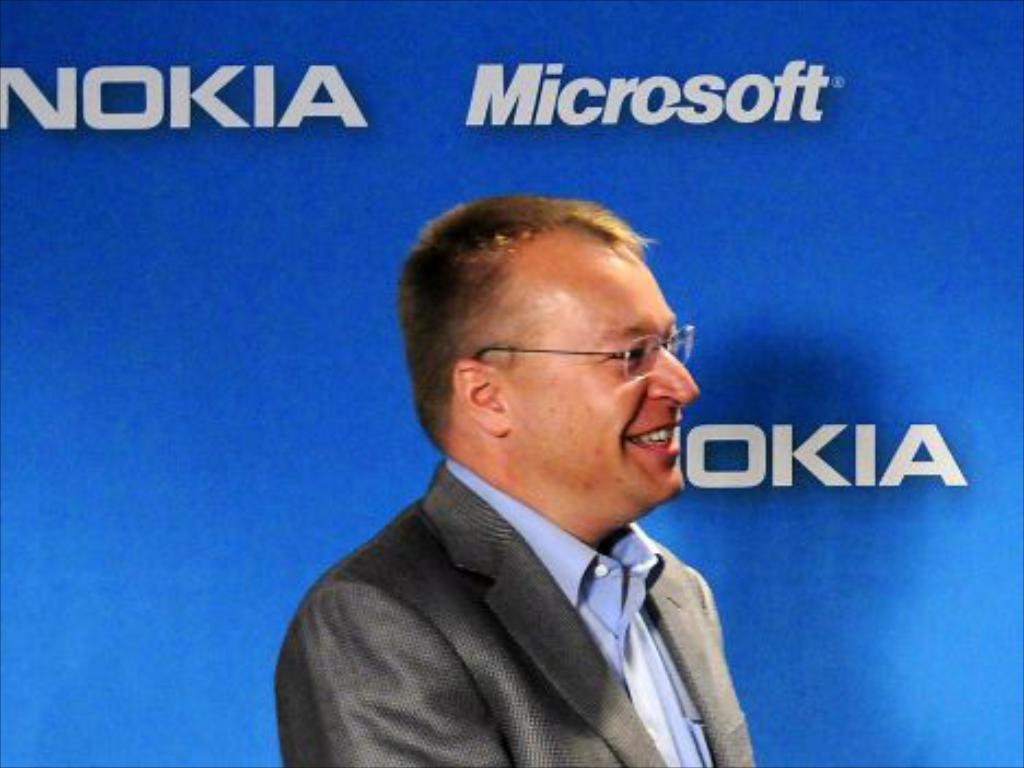What companies are featured in this image?
Keep it short and to the point. Nokia and microsoft. Which software company is featured?
Offer a terse response. Microsoft. 